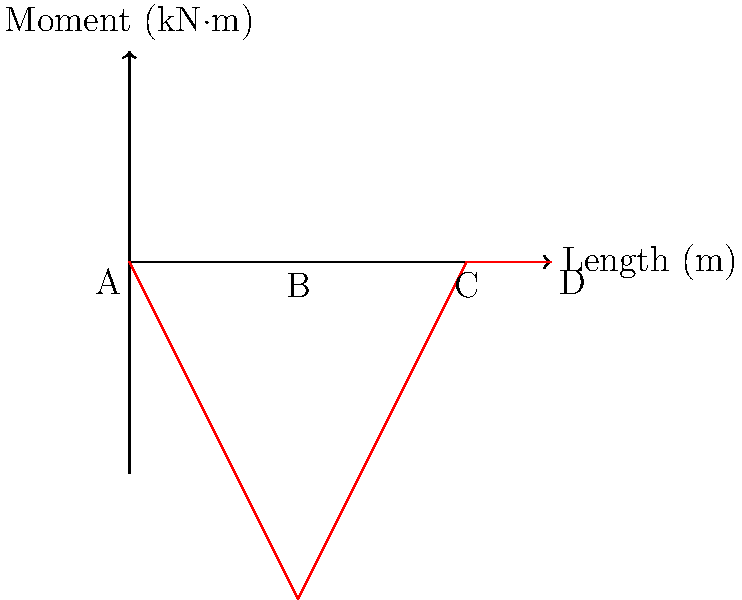The bending moment diagram for a simply supported beam ABCD is shown above. The beam has a length of 10 meters and is subjected to various loads. Given that the maximum bending stress occurs at point B and the beam has a rectangular cross-section with a width of 100 mm and a height of 200 mm, calculate the maximum bending stress in the beam. Use the formula $\sigma_{max} = \frac{M_max \cdot y}{I}$, where $M_{max}$ is the maximum bending moment, $y$ is the distance from the neutral axis to the outermost fiber, and $I$ is the moment of inertia of the cross-section. To solve this problem, let's follow these steps:

1) First, we need to determine the maximum bending moment ($M_{max}$) from the diagram. The diagram shows that the maximum moment occurs at point B, which is 4 meters from the left end. The value is 8 kN·m or 8,000,000 N·mm.

2) For a rectangular cross-section, the moment of inertia ($I$) is given by:
   
   $I = \frac{bh^3}{12}$

   where $b$ is the width and $h$ is the height of the cross-section.

3) Substituting the given values:
   
   $I = \frac{100 \cdot 200^3}{12} = 66,666,667$ mm⁴

4) The distance $y$ from the neutral axis to the outermost fiber is half the height of the beam:
   
   $y = \frac{200}{2} = 100$ mm

5) Now we can use the formula for maximum bending stress:

   $\sigma_{max} = \frac{M_{max} \cdot y}{I}$

6) Substituting our values:

   $\sigma_{max} = \frac{8,000,000 \cdot 100}{66,666,667} = 12$ MPa

Therefore, the maximum bending stress in the beam is 12 MPa.
Answer: 12 MPa 